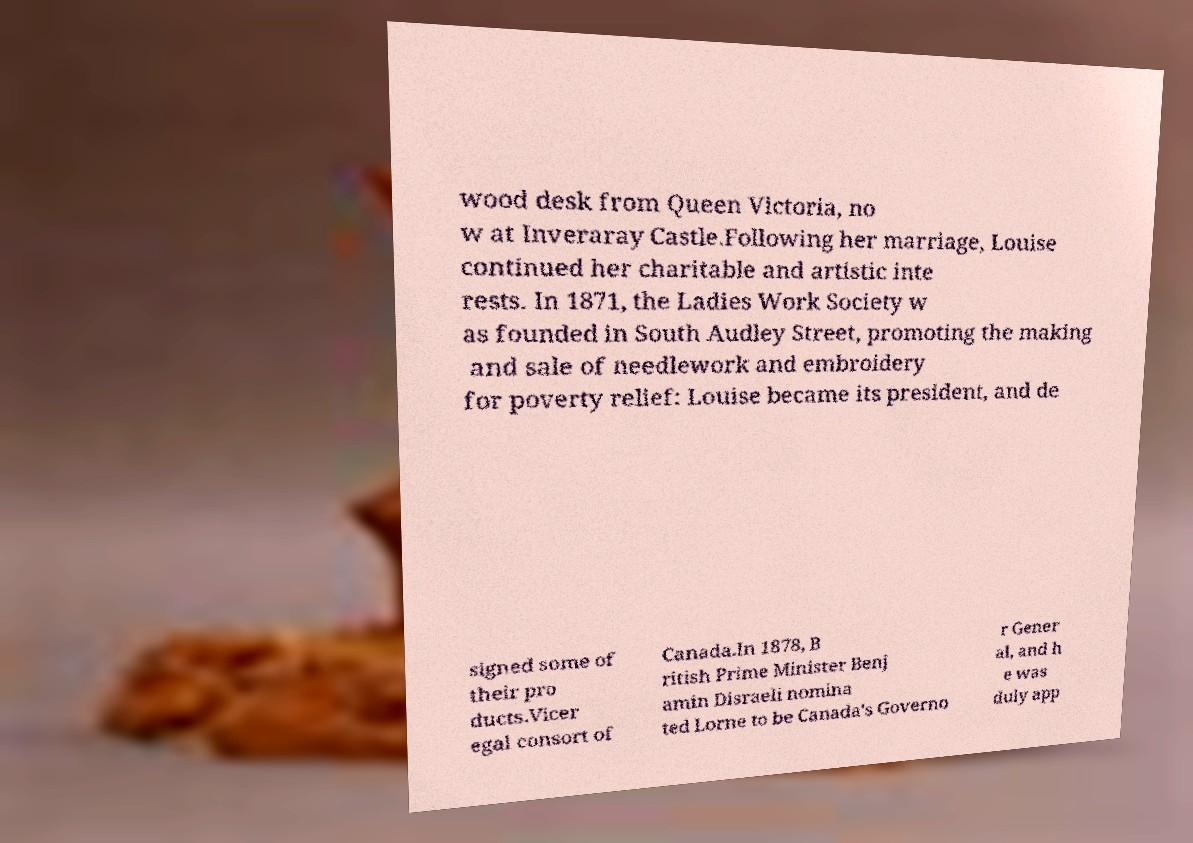What messages or text are displayed in this image? I need them in a readable, typed format. wood desk from Queen Victoria, no w at Inveraray Castle.Following her marriage, Louise continued her charitable and artistic inte rests. In 1871, the Ladies Work Society w as founded in South Audley Street, promoting the making and sale of needlework and embroidery for poverty relief: Louise became its president, and de signed some of their pro ducts.Vicer egal consort of Canada.In 1878, B ritish Prime Minister Benj amin Disraeli nomina ted Lorne to be Canada's Governo r Gener al, and h e was duly app 